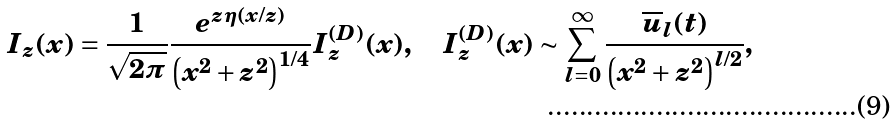<formula> <loc_0><loc_0><loc_500><loc_500>I _ { z } ( x ) = \frac { 1 } { \sqrt { 2 \pi } } \frac { e ^ { z \eta ( x / z ) } } { \left ( x ^ { 2 } + z ^ { 2 } \right ) ^ { 1 / 4 } } I _ { z } ^ { ( D ) } ( x ) , \quad I _ { z } ^ { ( D ) } ( x ) \sim \sum _ { l = 0 } ^ { \infty } \frac { \overline { u } _ { l } ( t ) } { \left ( x ^ { 2 } + z ^ { 2 } \right ) ^ { l / 2 } } ,</formula> 